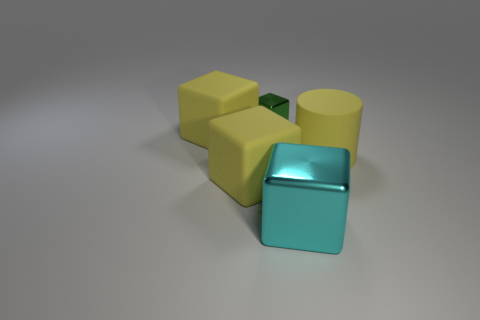What could be the function of these objects if they were part of a larger mechanism? If these objects were part of a larger mechanism, they could serve as components such as connectors, weights, or stands. For example, the cylinders might act as spacers or rollers, while the cube could be a connecting joint or pivot point. 